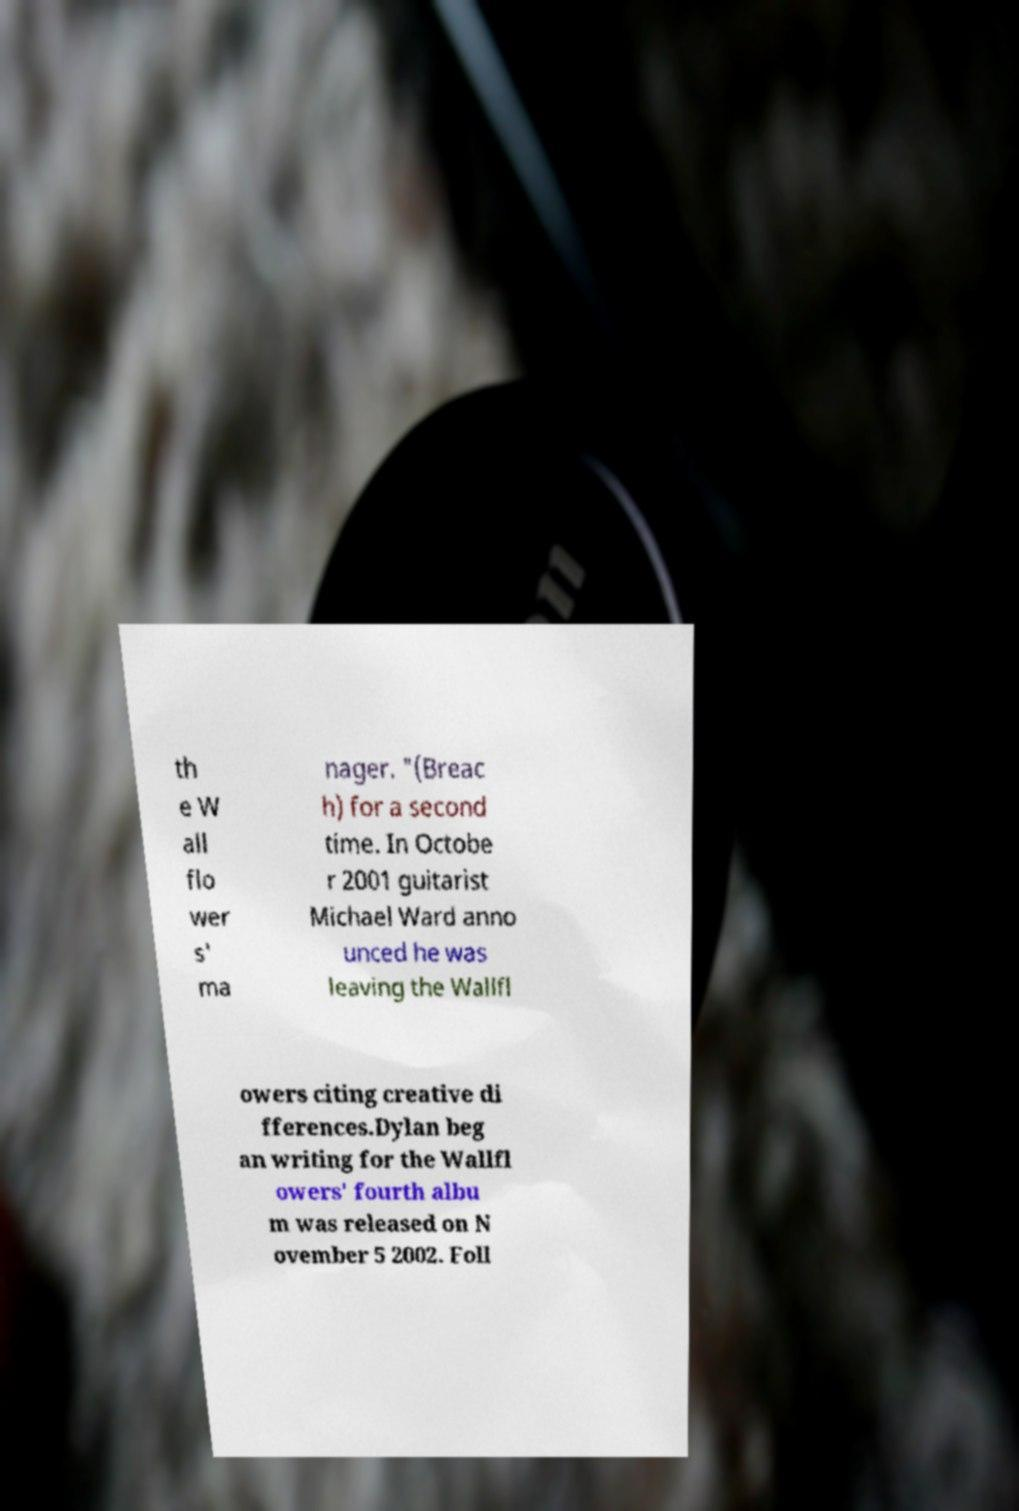Could you extract and type out the text from this image? th e W all flo wer s' ma nager. "(Breac h) for a second time. In Octobe r 2001 guitarist Michael Ward anno unced he was leaving the Wallfl owers citing creative di fferences.Dylan beg an writing for the Wallfl owers' fourth albu m was released on N ovember 5 2002. Foll 